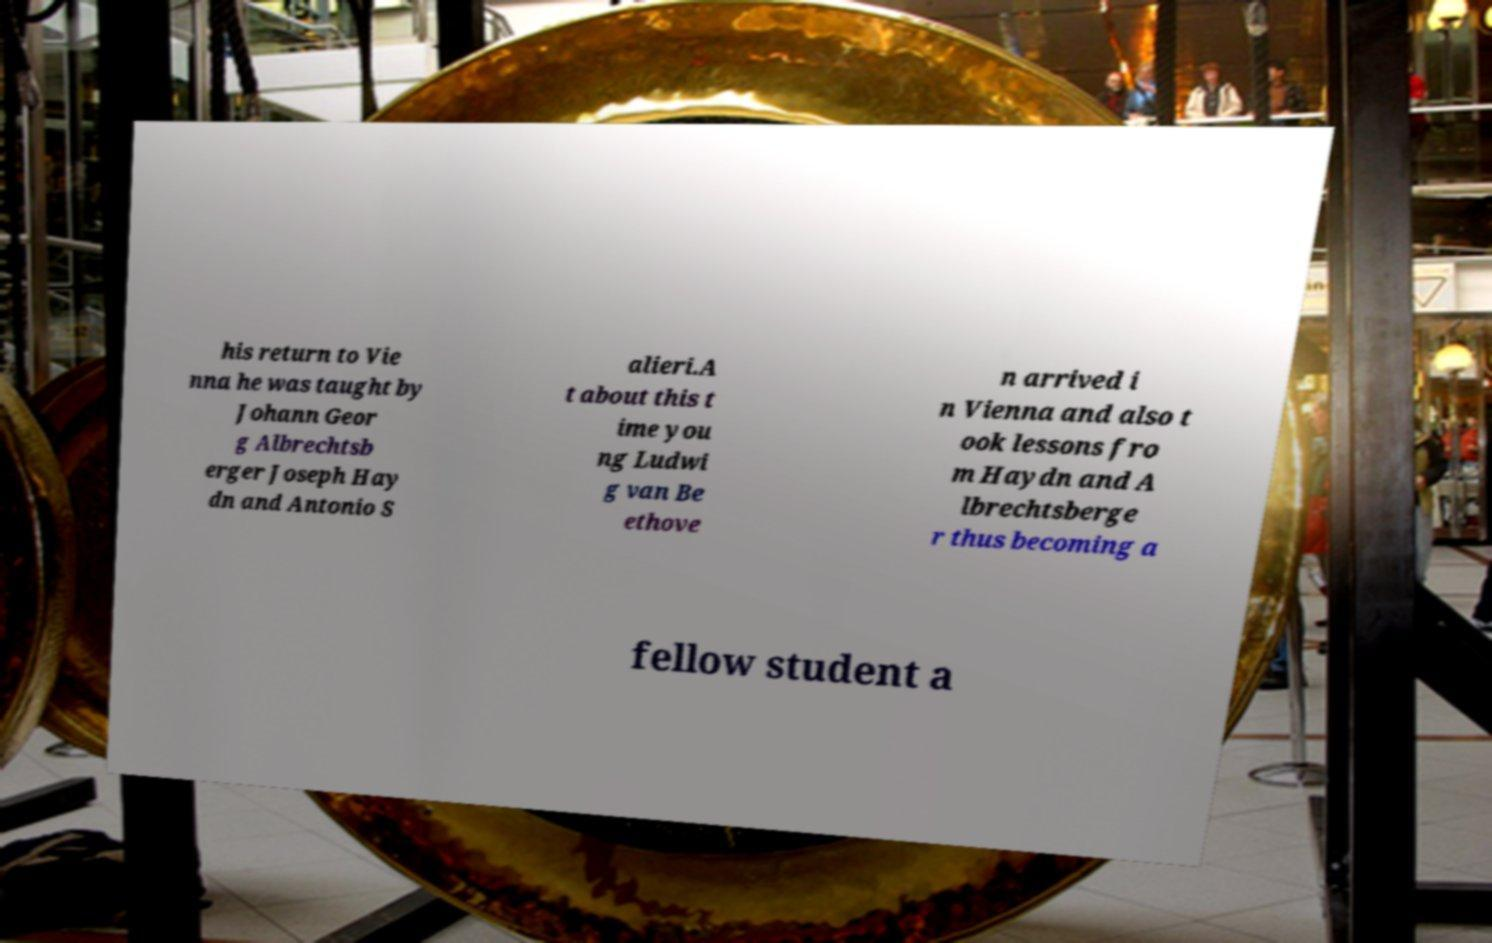Can you read and provide the text displayed in the image?This photo seems to have some interesting text. Can you extract and type it out for me? his return to Vie nna he was taught by Johann Geor g Albrechtsb erger Joseph Hay dn and Antonio S alieri.A t about this t ime you ng Ludwi g van Be ethove n arrived i n Vienna and also t ook lessons fro m Haydn and A lbrechtsberge r thus becoming a fellow student a 